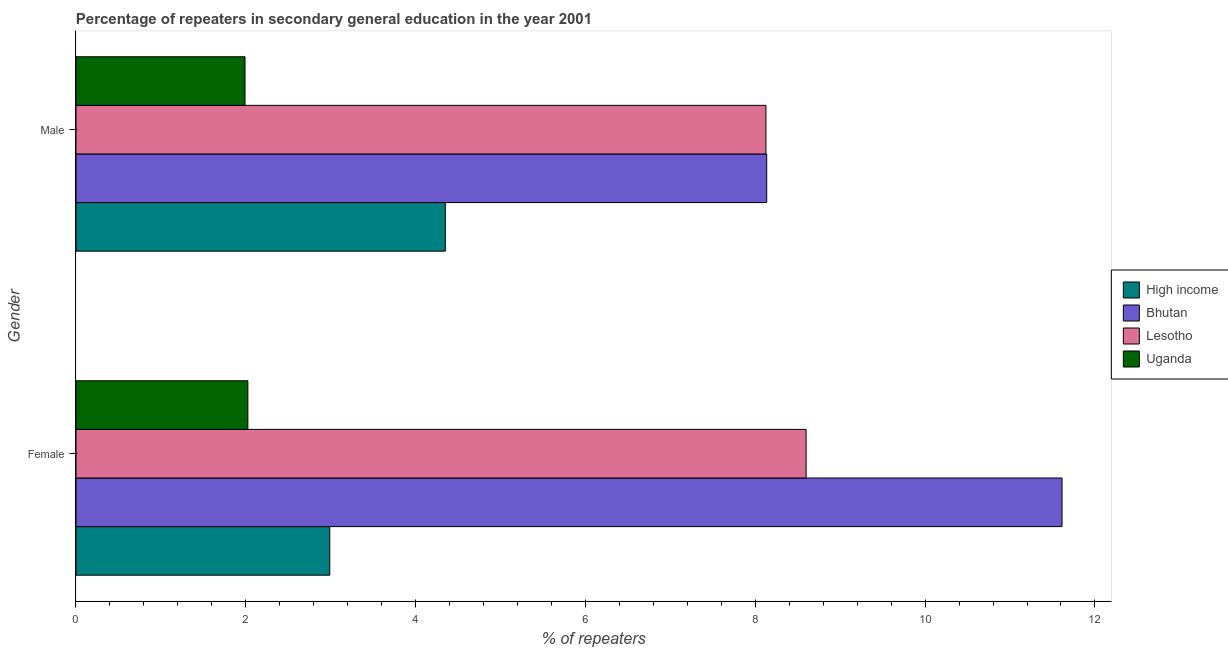How many different coloured bars are there?
Your response must be concise. 4. Are the number of bars per tick equal to the number of legend labels?
Make the answer very short. Yes. How many bars are there on the 2nd tick from the top?
Give a very brief answer. 4. What is the percentage of female repeaters in Lesotho?
Your answer should be compact. 8.6. Across all countries, what is the maximum percentage of male repeaters?
Provide a short and direct response. 8.13. Across all countries, what is the minimum percentage of female repeaters?
Your response must be concise. 2.02. In which country was the percentage of male repeaters maximum?
Keep it short and to the point. Bhutan. In which country was the percentage of female repeaters minimum?
Provide a succinct answer. Uganda. What is the total percentage of male repeaters in the graph?
Offer a very short reply. 22.6. What is the difference between the percentage of female repeaters in High income and that in Uganda?
Give a very brief answer. 0.96. What is the difference between the percentage of male repeaters in High income and the percentage of female repeaters in Uganda?
Ensure brevity in your answer.  2.33. What is the average percentage of male repeaters per country?
Your response must be concise. 5.65. What is the difference between the percentage of male repeaters and percentage of female repeaters in High income?
Give a very brief answer. 1.36. In how many countries, is the percentage of female repeaters greater than 3.2 %?
Make the answer very short. 2. What is the ratio of the percentage of female repeaters in Bhutan to that in High income?
Give a very brief answer. 3.89. Is the percentage of male repeaters in Bhutan less than that in High income?
Ensure brevity in your answer.  No. What does the 4th bar from the top in Female represents?
Make the answer very short. High income. What does the 2nd bar from the bottom in Male represents?
Provide a succinct answer. Bhutan. How many bars are there?
Provide a short and direct response. 8. How many countries are there in the graph?
Make the answer very short. 4. What is the difference between two consecutive major ticks on the X-axis?
Your response must be concise. 2. Are the values on the major ticks of X-axis written in scientific E-notation?
Make the answer very short. No. Does the graph contain any zero values?
Provide a succinct answer. No. Does the graph contain grids?
Your response must be concise. No. How many legend labels are there?
Provide a succinct answer. 4. What is the title of the graph?
Offer a very short reply. Percentage of repeaters in secondary general education in the year 2001. What is the label or title of the X-axis?
Provide a short and direct response. % of repeaters. What is the label or title of the Y-axis?
Your answer should be very brief. Gender. What is the % of repeaters in High income in Female?
Give a very brief answer. 2.99. What is the % of repeaters in Bhutan in Female?
Offer a terse response. 11.61. What is the % of repeaters in Lesotho in Female?
Give a very brief answer. 8.6. What is the % of repeaters in Uganda in Female?
Provide a succinct answer. 2.02. What is the % of repeaters in High income in Male?
Your answer should be very brief. 4.35. What is the % of repeaters in Bhutan in Male?
Provide a succinct answer. 8.13. What is the % of repeaters of Lesotho in Male?
Offer a terse response. 8.13. What is the % of repeaters in Uganda in Male?
Keep it short and to the point. 1.99. Across all Gender, what is the maximum % of repeaters in High income?
Your answer should be compact. 4.35. Across all Gender, what is the maximum % of repeaters of Bhutan?
Provide a succinct answer. 11.61. Across all Gender, what is the maximum % of repeaters in Lesotho?
Your answer should be compact. 8.6. Across all Gender, what is the maximum % of repeaters in Uganda?
Your response must be concise. 2.02. Across all Gender, what is the minimum % of repeaters in High income?
Ensure brevity in your answer.  2.99. Across all Gender, what is the minimum % of repeaters in Bhutan?
Give a very brief answer. 8.13. Across all Gender, what is the minimum % of repeaters of Lesotho?
Ensure brevity in your answer.  8.13. Across all Gender, what is the minimum % of repeaters in Uganda?
Provide a succinct answer. 1.99. What is the total % of repeaters in High income in the graph?
Give a very brief answer. 7.34. What is the total % of repeaters of Bhutan in the graph?
Provide a succinct answer. 19.75. What is the total % of repeaters in Lesotho in the graph?
Provide a short and direct response. 16.72. What is the total % of repeaters in Uganda in the graph?
Provide a short and direct response. 4.01. What is the difference between the % of repeaters in High income in Female and that in Male?
Offer a very short reply. -1.36. What is the difference between the % of repeaters in Bhutan in Female and that in Male?
Offer a terse response. 3.48. What is the difference between the % of repeaters in Lesotho in Female and that in Male?
Keep it short and to the point. 0.47. What is the difference between the % of repeaters in Uganda in Female and that in Male?
Ensure brevity in your answer.  0.03. What is the difference between the % of repeaters of High income in Female and the % of repeaters of Bhutan in Male?
Provide a short and direct response. -5.15. What is the difference between the % of repeaters in High income in Female and the % of repeaters in Lesotho in Male?
Provide a short and direct response. -5.14. What is the difference between the % of repeaters of Bhutan in Female and the % of repeaters of Lesotho in Male?
Make the answer very short. 3.49. What is the difference between the % of repeaters of Bhutan in Female and the % of repeaters of Uganda in Male?
Your response must be concise. 9.62. What is the difference between the % of repeaters in Lesotho in Female and the % of repeaters in Uganda in Male?
Provide a short and direct response. 6.61. What is the average % of repeaters of High income per Gender?
Keep it short and to the point. 3.67. What is the average % of repeaters in Bhutan per Gender?
Make the answer very short. 9.87. What is the average % of repeaters in Lesotho per Gender?
Make the answer very short. 8.36. What is the average % of repeaters of Uganda per Gender?
Keep it short and to the point. 2.01. What is the difference between the % of repeaters of High income and % of repeaters of Bhutan in Female?
Provide a short and direct response. -8.62. What is the difference between the % of repeaters in High income and % of repeaters in Lesotho in Female?
Keep it short and to the point. -5.61. What is the difference between the % of repeaters in High income and % of repeaters in Uganda in Female?
Ensure brevity in your answer.  0.96. What is the difference between the % of repeaters of Bhutan and % of repeaters of Lesotho in Female?
Keep it short and to the point. 3.01. What is the difference between the % of repeaters of Bhutan and % of repeaters of Uganda in Female?
Your answer should be very brief. 9.59. What is the difference between the % of repeaters in Lesotho and % of repeaters in Uganda in Female?
Your answer should be compact. 6.57. What is the difference between the % of repeaters in High income and % of repeaters in Bhutan in Male?
Give a very brief answer. -3.78. What is the difference between the % of repeaters in High income and % of repeaters in Lesotho in Male?
Provide a short and direct response. -3.78. What is the difference between the % of repeaters of High income and % of repeaters of Uganda in Male?
Offer a terse response. 2.36. What is the difference between the % of repeaters in Bhutan and % of repeaters in Lesotho in Male?
Provide a succinct answer. 0.01. What is the difference between the % of repeaters of Bhutan and % of repeaters of Uganda in Male?
Keep it short and to the point. 6.14. What is the difference between the % of repeaters of Lesotho and % of repeaters of Uganda in Male?
Keep it short and to the point. 6.13. What is the ratio of the % of repeaters of High income in Female to that in Male?
Give a very brief answer. 0.69. What is the ratio of the % of repeaters of Bhutan in Female to that in Male?
Offer a terse response. 1.43. What is the ratio of the % of repeaters of Lesotho in Female to that in Male?
Provide a succinct answer. 1.06. What is the ratio of the % of repeaters in Uganda in Female to that in Male?
Ensure brevity in your answer.  1.02. What is the difference between the highest and the second highest % of repeaters of High income?
Your answer should be very brief. 1.36. What is the difference between the highest and the second highest % of repeaters of Bhutan?
Offer a terse response. 3.48. What is the difference between the highest and the second highest % of repeaters in Lesotho?
Make the answer very short. 0.47. What is the difference between the highest and the second highest % of repeaters of Uganda?
Keep it short and to the point. 0.03. What is the difference between the highest and the lowest % of repeaters of High income?
Provide a succinct answer. 1.36. What is the difference between the highest and the lowest % of repeaters in Bhutan?
Provide a succinct answer. 3.48. What is the difference between the highest and the lowest % of repeaters of Lesotho?
Your answer should be compact. 0.47. What is the difference between the highest and the lowest % of repeaters in Uganda?
Your answer should be very brief. 0.03. 